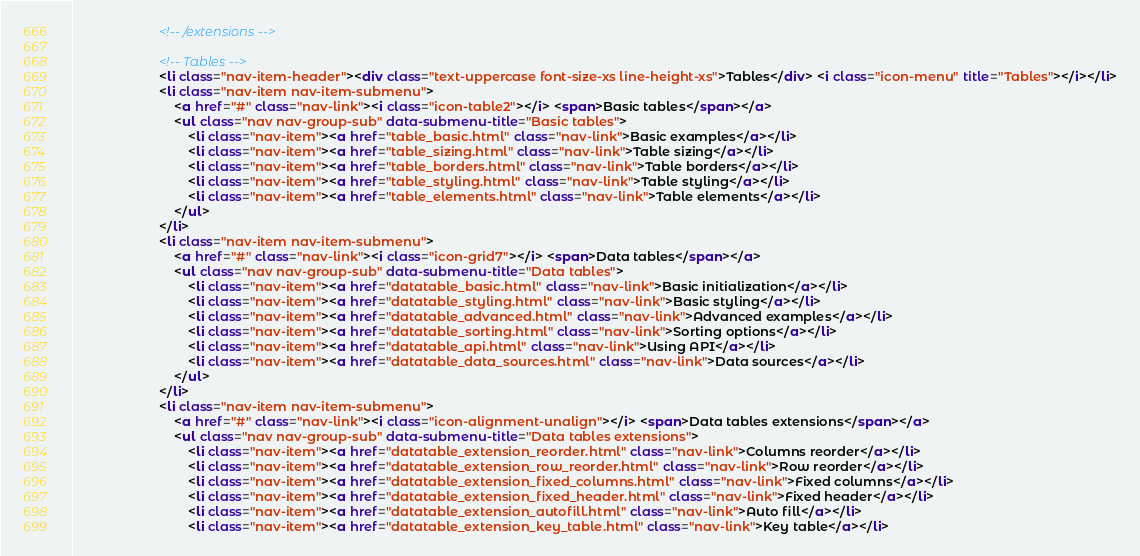Convert code to text. <code><loc_0><loc_0><loc_500><loc_500><_HTML_>						<!-- /extensions -->

						<!-- Tables -->
						<li class="nav-item-header"><div class="text-uppercase font-size-xs line-height-xs">Tables</div> <i class="icon-menu" title="Tables"></i></li>
						<li class="nav-item nav-item-submenu">
							<a href="#" class="nav-link"><i class="icon-table2"></i> <span>Basic tables</span></a>
							<ul class="nav nav-group-sub" data-submenu-title="Basic tables">
								<li class="nav-item"><a href="table_basic.html" class="nav-link">Basic examples</a></li>
								<li class="nav-item"><a href="table_sizing.html" class="nav-link">Table sizing</a></li>
								<li class="nav-item"><a href="table_borders.html" class="nav-link">Table borders</a></li>
								<li class="nav-item"><a href="table_styling.html" class="nav-link">Table styling</a></li>
								<li class="nav-item"><a href="table_elements.html" class="nav-link">Table elements</a></li>
							</ul>
						</li>
						<li class="nav-item nav-item-submenu">
							<a href="#" class="nav-link"><i class="icon-grid7"></i> <span>Data tables</span></a>
							<ul class="nav nav-group-sub" data-submenu-title="Data tables">
								<li class="nav-item"><a href="datatable_basic.html" class="nav-link">Basic initialization</a></li>
								<li class="nav-item"><a href="datatable_styling.html" class="nav-link">Basic styling</a></li>
								<li class="nav-item"><a href="datatable_advanced.html" class="nav-link">Advanced examples</a></li>
								<li class="nav-item"><a href="datatable_sorting.html" class="nav-link">Sorting options</a></li>
								<li class="nav-item"><a href="datatable_api.html" class="nav-link">Using API</a></li>
								<li class="nav-item"><a href="datatable_data_sources.html" class="nav-link">Data sources</a></li>
							</ul>
						</li>
						<li class="nav-item nav-item-submenu">
							<a href="#" class="nav-link"><i class="icon-alignment-unalign"></i> <span>Data tables extensions</span></a>
							<ul class="nav nav-group-sub" data-submenu-title="Data tables extensions">
								<li class="nav-item"><a href="datatable_extension_reorder.html" class="nav-link">Columns reorder</a></li>
								<li class="nav-item"><a href="datatable_extension_row_reorder.html" class="nav-link">Row reorder</a></li>
								<li class="nav-item"><a href="datatable_extension_fixed_columns.html" class="nav-link">Fixed columns</a></li>
								<li class="nav-item"><a href="datatable_extension_fixed_header.html" class="nav-link">Fixed header</a></li>
								<li class="nav-item"><a href="datatable_extension_autofill.html" class="nav-link">Auto fill</a></li>
								<li class="nav-item"><a href="datatable_extension_key_table.html" class="nav-link">Key table</a></li></code> 